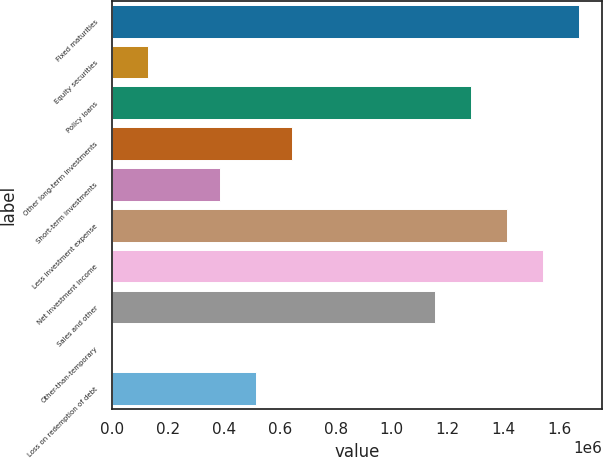<chart> <loc_0><loc_0><loc_500><loc_500><bar_chart><fcel>Fixed maturities<fcel>Equity securities<fcel>Policy loans<fcel>Other long-term investments<fcel>Short-term investments<fcel>Less investment expense<fcel>Net investment income<fcel>Sales and other<fcel>Other-than-temporary<fcel>Loss on redemption of debt<nl><fcel>1.66798e+06<fcel>128310<fcel>1.28306e+06<fcel>641533<fcel>384921<fcel>1.41137e+06<fcel>1.53967e+06<fcel>1.15476e+06<fcel>4.09<fcel>513227<nl></chart> 